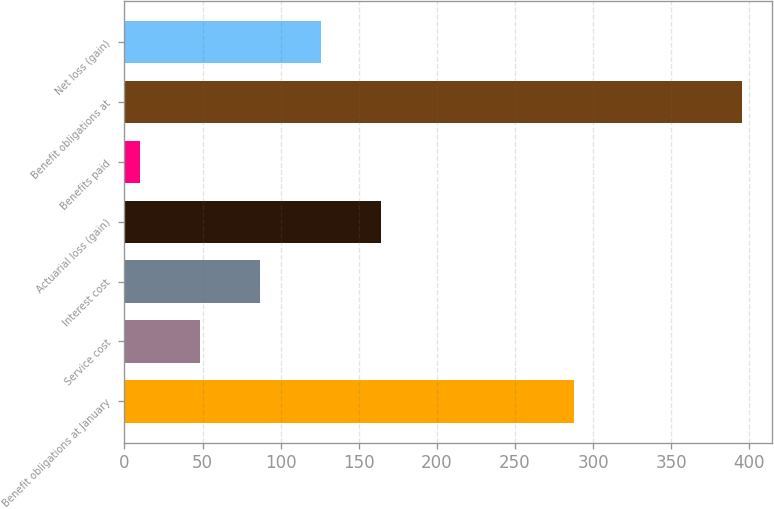<chart> <loc_0><loc_0><loc_500><loc_500><bar_chart><fcel>Benefit obligations at January<fcel>Service cost<fcel>Interest cost<fcel>Actuarial loss (gain)<fcel>Benefits paid<fcel>Benefit obligations at<fcel>Net loss (gain)<nl><fcel>288<fcel>48.5<fcel>87<fcel>164<fcel>10<fcel>395<fcel>125.5<nl></chart> 